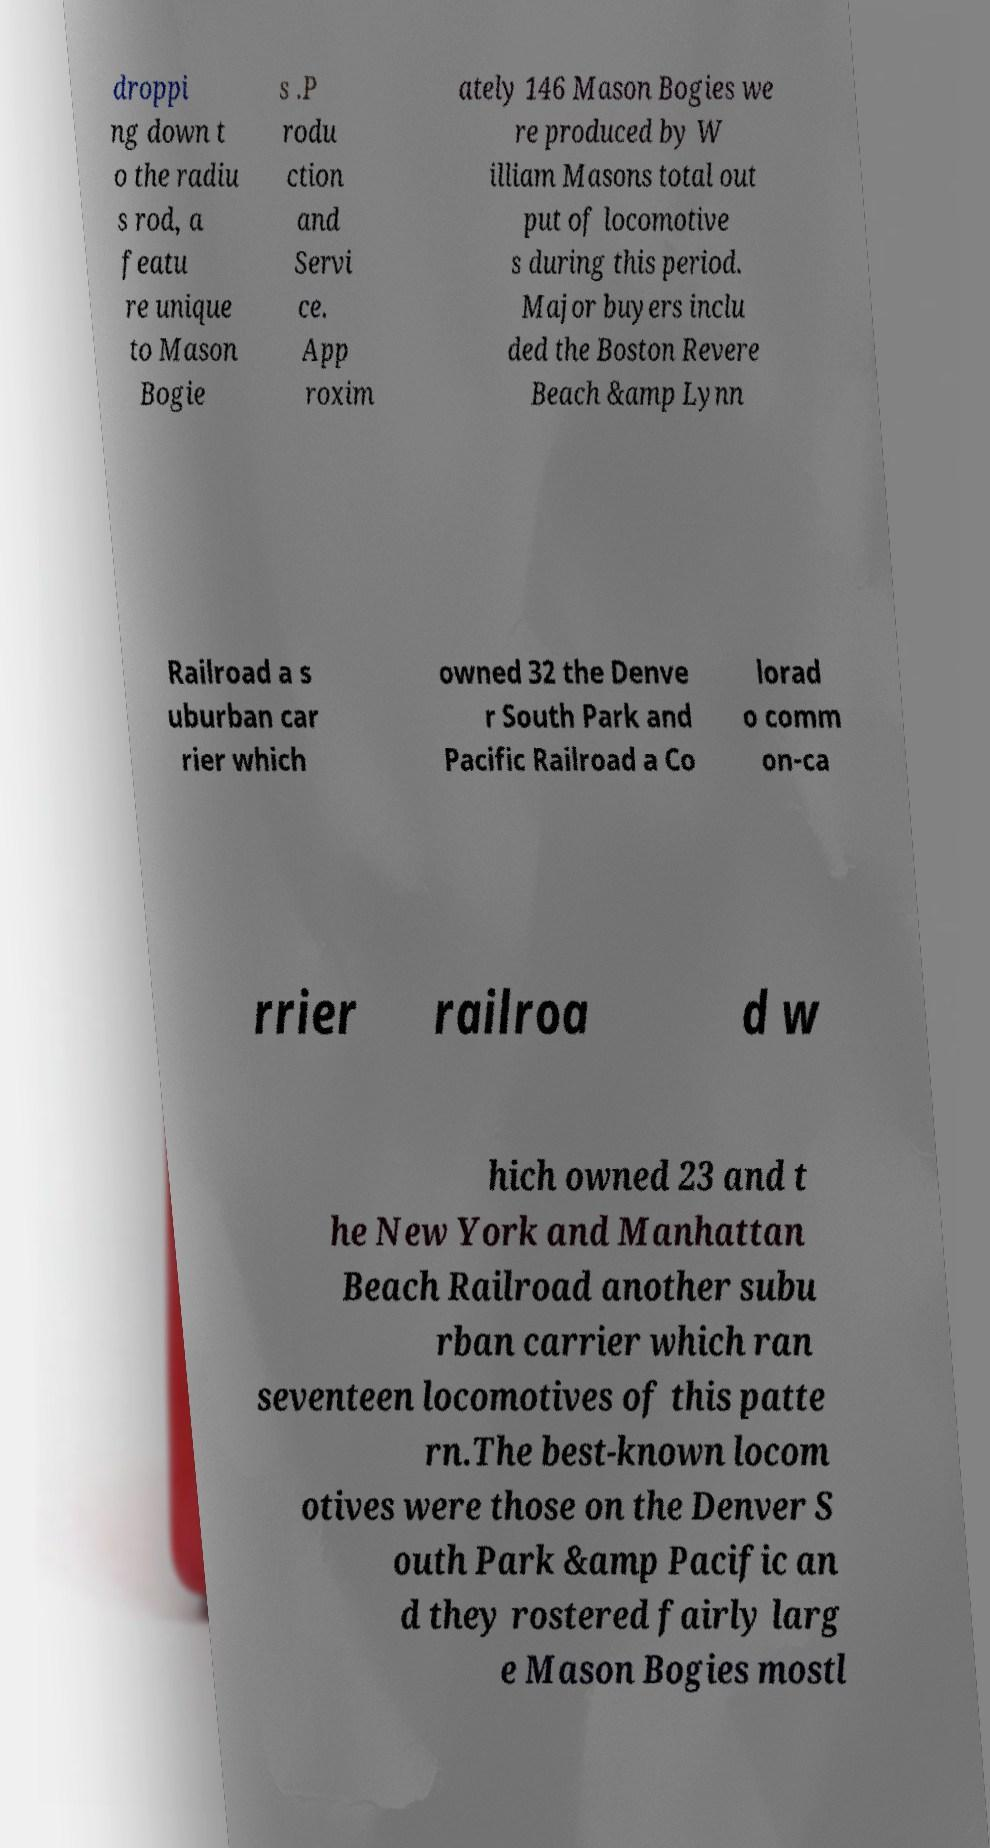Please read and relay the text visible in this image. What does it say? droppi ng down t o the radiu s rod, a featu re unique to Mason Bogie s .P rodu ction and Servi ce. App roxim ately 146 Mason Bogies we re produced by W illiam Masons total out put of locomotive s during this period. Major buyers inclu ded the Boston Revere Beach &amp Lynn Railroad a s uburban car rier which owned 32 the Denve r South Park and Pacific Railroad a Co lorad o comm on-ca rrier railroa d w hich owned 23 and t he New York and Manhattan Beach Railroad another subu rban carrier which ran seventeen locomotives of this patte rn.The best-known locom otives were those on the Denver S outh Park &amp Pacific an d they rostered fairly larg e Mason Bogies mostl 